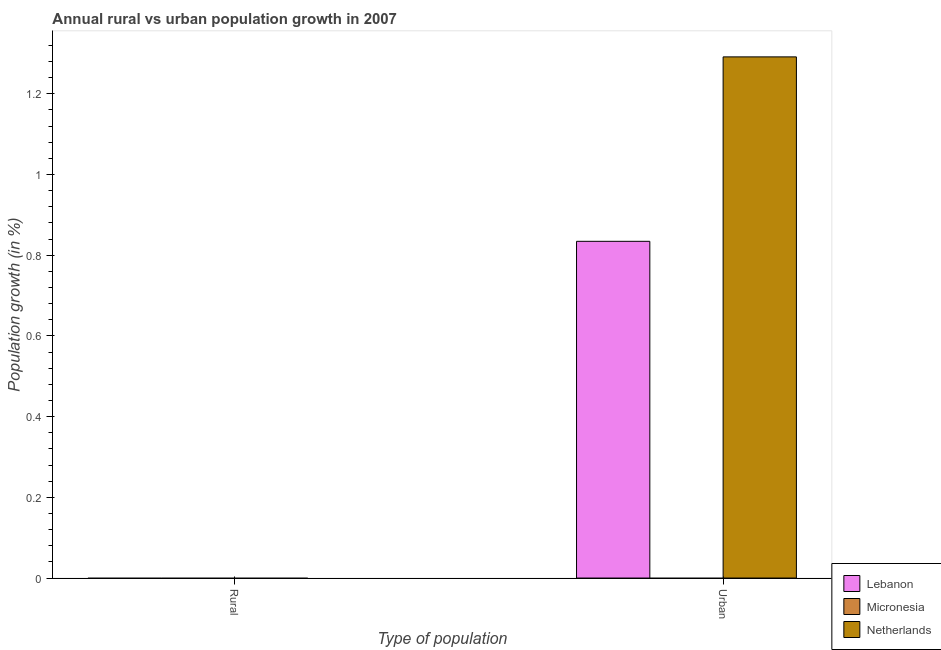Are the number of bars on each tick of the X-axis equal?
Offer a terse response. No. How many bars are there on the 2nd tick from the right?
Provide a short and direct response. 0. What is the label of the 1st group of bars from the left?
Ensure brevity in your answer.  Rural. What is the rural population growth in Netherlands?
Ensure brevity in your answer.  0. Across all countries, what is the maximum urban population growth?
Your response must be concise. 1.29. Across all countries, what is the minimum rural population growth?
Give a very brief answer. 0. In which country was the urban population growth maximum?
Provide a succinct answer. Netherlands. What is the difference between the urban population growth in Lebanon and that in Netherlands?
Ensure brevity in your answer.  -0.46. What is the difference between the rural population growth in Netherlands and the urban population growth in Lebanon?
Offer a terse response. -0.83. What is the average urban population growth per country?
Your answer should be compact. 0.71. In how many countries, is the urban population growth greater than 0.32 %?
Your answer should be compact. 2. What is the ratio of the urban population growth in Lebanon to that in Netherlands?
Give a very brief answer. 0.65. In how many countries, is the rural population growth greater than the average rural population growth taken over all countries?
Provide a short and direct response. 0. Are all the bars in the graph horizontal?
Keep it short and to the point. No. How many countries are there in the graph?
Make the answer very short. 3. Are the values on the major ticks of Y-axis written in scientific E-notation?
Your answer should be very brief. No. Does the graph contain any zero values?
Your response must be concise. Yes. Where does the legend appear in the graph?
Your response must be concise. Bottom right. How many legend labels are there?
Make the answer very short. 3. How are the legend labels stacked?
Offer a terse response. Vertical. What is the title of the graph?
Your answer should be very brief. Annual rural vs urban population growth in 2007. Does "Guinea" appear as one of the legend labels in the graph?
Provide a short and direct response. No. What is the label or title of the X-axis?
Give a very brief answer. Type of population. What is the label or title of the Y-axis?
Your response must be concise. Population growth (in %). What is the Population growth (in %) of Lebanon in Rural?
Your answer should be compact. 0. What is the Population growth (in %) of Lebanon in Urban ?
Offer a terse response. 0.83. What is the Population growth (in %) in Micronesia in Urban ?
Provide a succinct answer. 0. What is the Population growth (in %) of Netherlands in Urban ?
Your answer should be very brief. 1.29. Across all Type of population, what is the maximum Population growth (in %) of Lebanon?
Provide a succinct answer. 0.83. Across all Type of population, what is the maximum Population growth (in %) of Netherlands?
Make the answer very short. 1.29. Across all Type of population, what is the minimum Population growth (in %) of Lebanon?
Offer a very short reply. 0. Across all Type of population, what is the minimum Population growth (in %) of Netherlands?
Provide a succinct answer. 0. What is the total Population growth (in %) of Lebanon in the graph?
Provide a short and direct response. 0.83. What is the total Population growth (in %) in Micronesia in the graph?
Your answer should be compact. 0. What is the total Population growth (in %) in Netherlands in the graph?
Your answer should be compact. 1.29. What is the average Population growth (in %) in Lebanon per Type of population?
Make the answer very short. 0.42. What is the average Population growth (in %) of Micronesia per Type of population?
Keep it short and to the point. 0. What is the average Population growth (in %) of Netherlands per Type of population?
Make the answer very short. 0.65. What is the difference between the Population growth (in %) in Lebanon and Population growth (in %) in Netherlands in Urban ?
Your response must be concise. -0.46. What is the difference between the highest and the lowest Population growth (in %) in Lebanon?
Offer a terse response. 0.83. What is the difference between the highest and the lowest Population growth (in %) of Netherlands?
Keep it short and to the point. 1.29. 